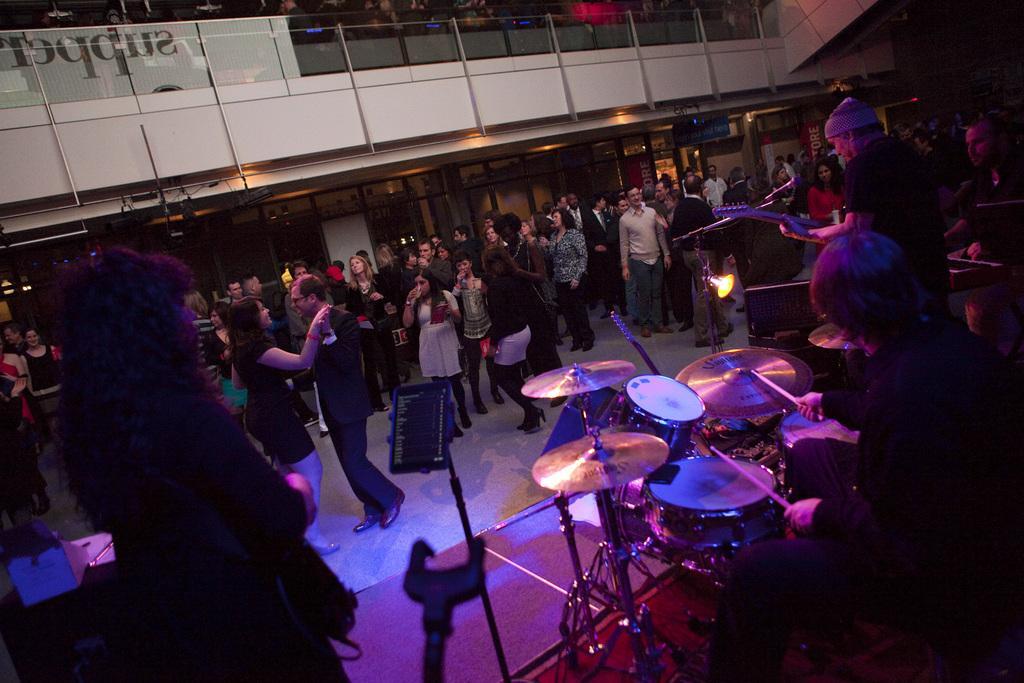In one or two sentences, can you explain what this image depicts? On the right side of the image few people are playing some musical instruments. Behind them few people are standing and dancing. At the top of the image there is fencing. Behind the fencing few people are standing and watching. 